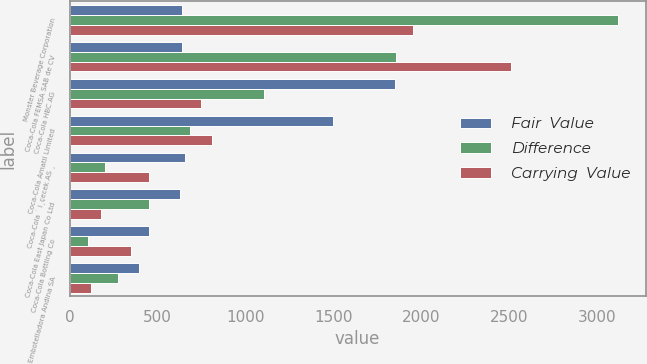Convert chart to OTSL. <chart><loc_0><loc_0><loc_500><loc_500><stacked_bar_chart><ecel><fcel>Monster Beverage Corporation<fcel>Coca-Cola FEMSA SAB de CV<fcel>Coca-Cola HBC AG<fcel>Coca-Cola Amatil Limited<fcel>Coca-Cola ˙ I¸çecek AS ¸<fcel>Coca-Cola East Japan Co Ltd<fcel>Coca-Cola Bottling Co<fcel>Embotelladora Andina SA<nl><fcel>Fair  Value<fcel>640<fcel>640<fcel>1851<fcel>1496<fcel>653<fcel>627<fcel>453<fcel>396<nl><fcel>Difference<fcel>3118<fcel>1853<fcel>1105<fcel>685<fcel>202<fcel>448<fcel>104<fcel>275<nl><fcel>Carrying  Value<fcel>1953<fcel>2507<fcel>746<fcel>811<fcel>451<fcel>179<fcel>349<fcel>121<nl></chart> 